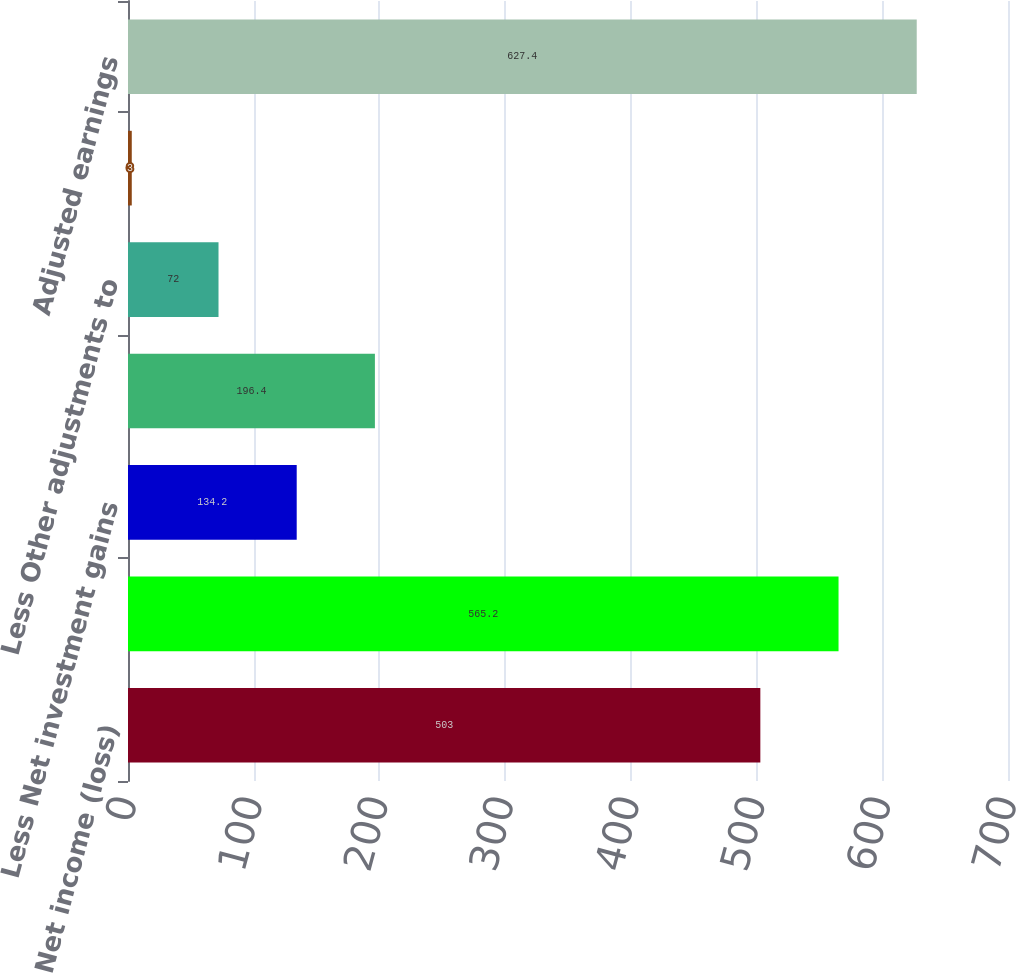<chart> <loc_0><loc_0><loc_500><loc_500><bar_chart><fcel>Net income (loss)<fcel>Income (loss) from continuing<fcel>Less Net investment gains<fcel>Less Net derivative gains<fcel>Less Other adjustments to<fcel>Less Provision for income tax<fcel>Adjusted earnings<nl><fcel>503<fcel>565.2<fcel>134.2<fcel>196.4<fcel>72<fcel>3<fcel>627.4<nl></chart> 